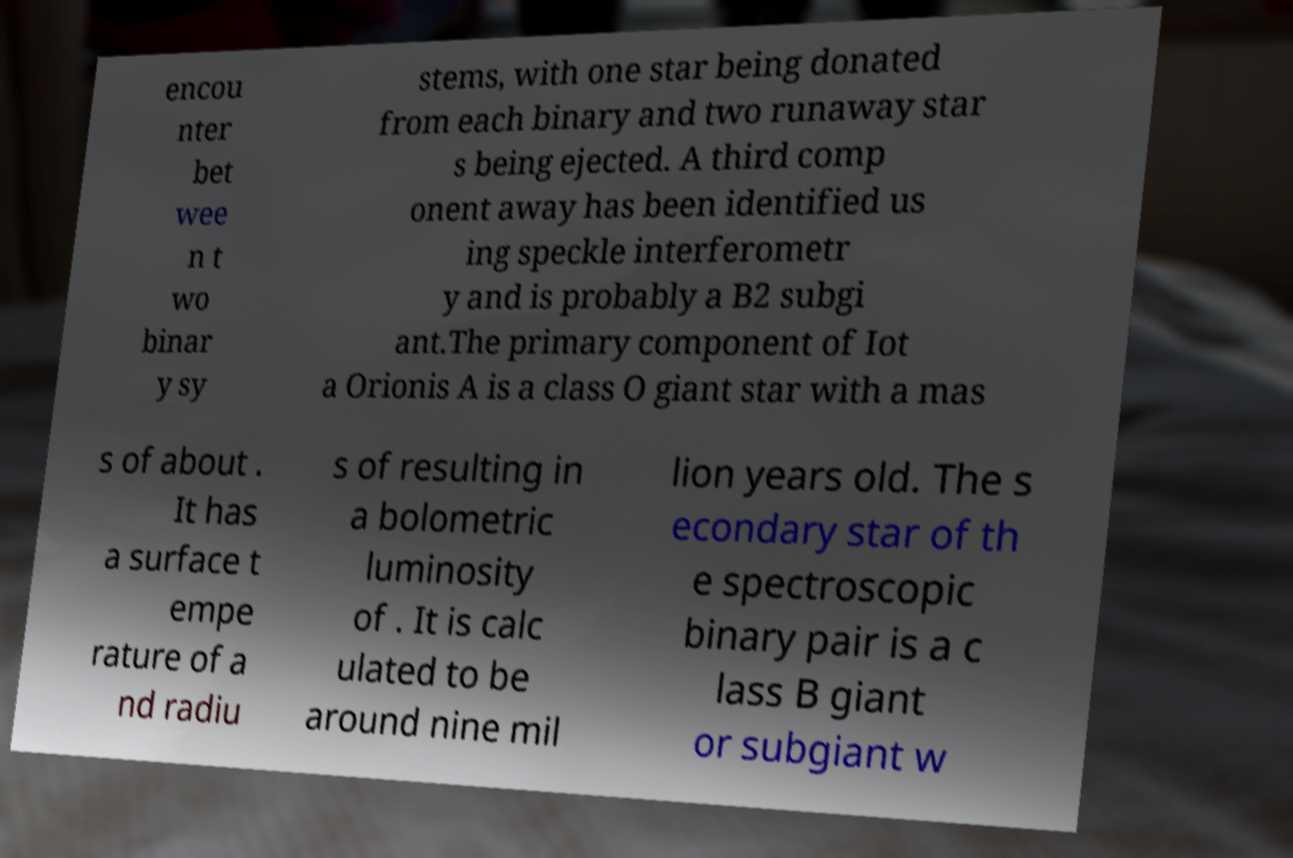There's text embedded in this image that I need extracted. Can you transcribe it verbatim? encou nter bet wee n t wo binar y sy stems, with one star being donated from each binary and two runaway star s being ejected. A third comp onent away has been identified us ing speckle interferometr y and is probably a B2 subgi ant.The primary component of Iot a Orionis A is a class O giant star with a mas s of about . It has a surface t empe rature of a nd radiu s of resulting in a bolometric luminosity of . It is calc ulated to be around nine mil lion years old. The s econdary star of th e spectroscopic binary pair is a c lass B giant or subgiant w 